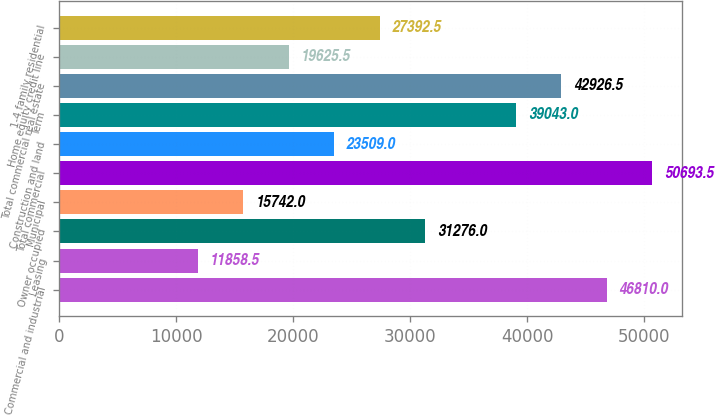Convert chart to OTSL. <chart><loc_0><loc_0><loc_500><loc_500><bar_chart><fcel>Commercial and industrial<fcel>Leasing<fcel>Owner occupied<fcel>Municipal<fcel>Total commercial<fcel>Construction and land<fcel>Term<fcel>Total commercial real estate<fcel>Home equity credit line<fcel>1-4 family residential<nl><fcel>46810<fcel>11858.5<fcel>31276<fcel>15742<fcel>50693.5<fcel>23509<fcel>39043<fcel>42926.5<fcel>19625.5<fcel>27392.5<nl></chart> 